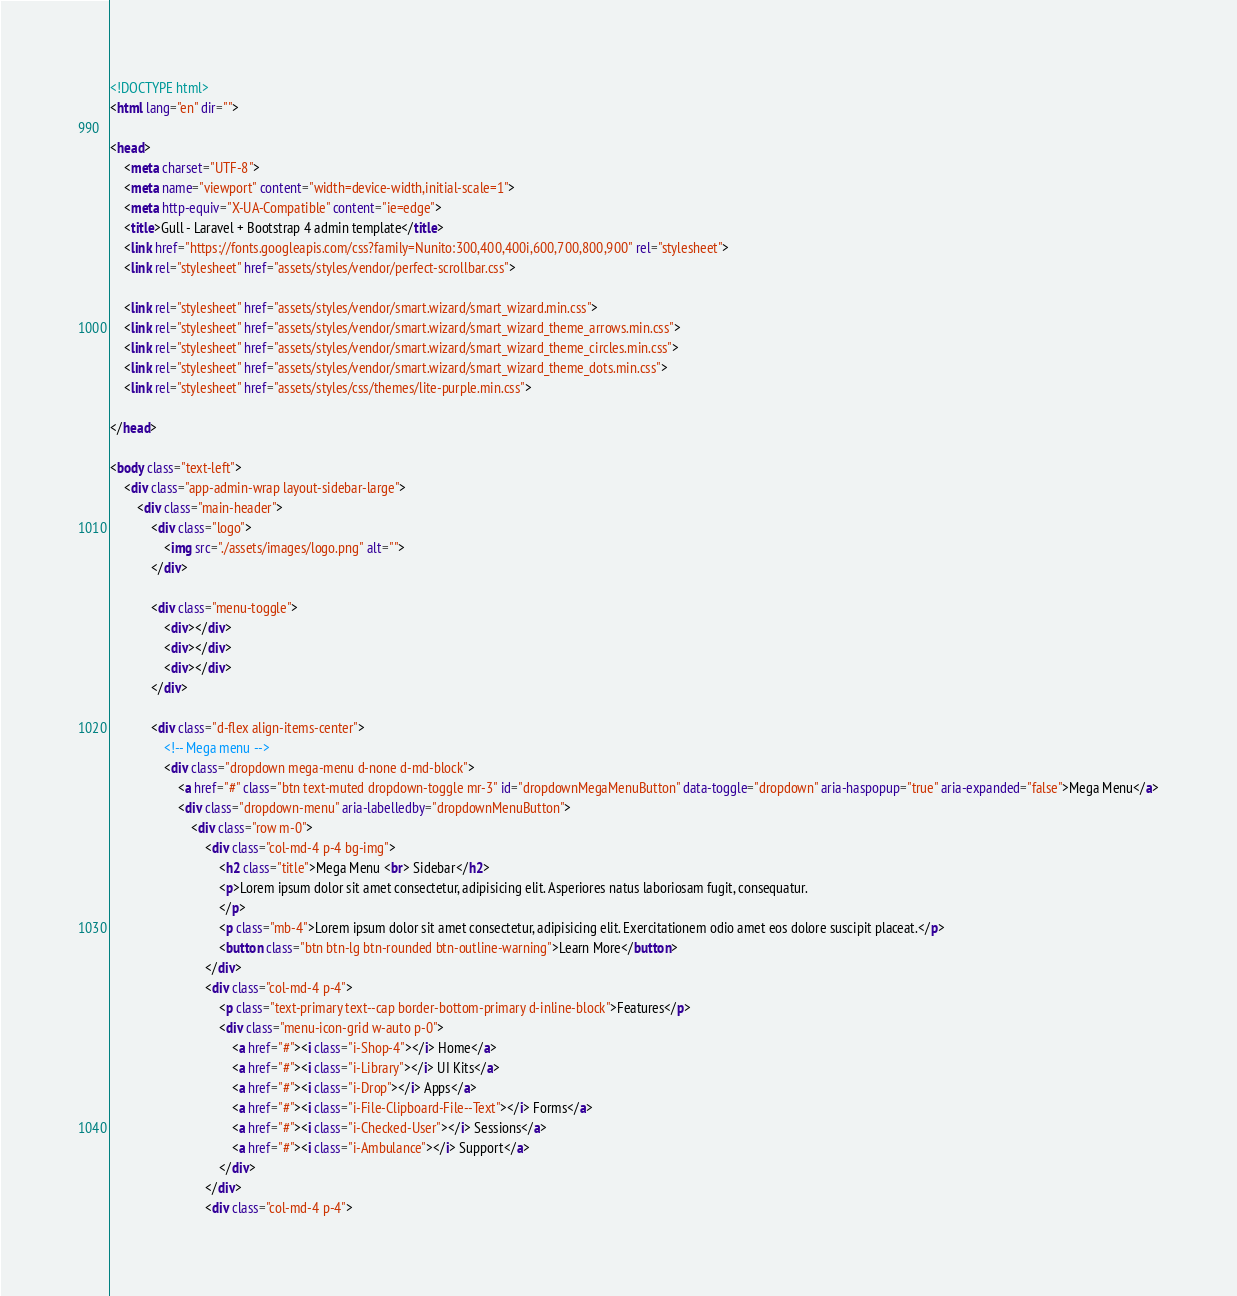<code> <loc_0><loc_0><loc_500><loc_500><_HTML_><!DOCTYPE html>
<html lang="en" dir="">

<head>
    <meta charset="UTF-8">
    <meta name="viewport" content="width=device-width,initial-scale=1">
    <meta http-equiv="X-UA-Compatible" content="ie=edge">
    <title>Gull - Laravel + Bootstrap 4 admin template</title>
    <link href="https://fonts.googleapis.com/css?family=Nunito:300,400,400i,600,700,800,900" rel="stylesheet">
    <link rel="stylesheet" href="assets/styles/vendor/perfect-scrollbar.css">

    <link rel="stylesheet" href="assets/styles/vendor/smart.wizard/smart_wizard.min.css">
    <link rel="stylesheet" href="assets/styles/vendor/smart.wizard/smart_wizard_theme_arrows.min.css">
    <link rel="stylesheet" href="assets/styles/vendor/smart.wizard/smart_wizard_theme_circles.min.css">
    <link rel="stylesheet" href="assets/styles/vendor/smart.wizard/smart_wizard_theme_dots.min.css">
    <link rel="stylesheet" href="assets/styles/css/themes/lite-purple.min.css">

</head>

<body class="text-left">
    <div class="app-admin-wrap layout-sidebar-large">
        <div class="main-header">
            <div class="logo">
                <img src="./assets/images/logo.png" alt="">
            </div>

            <div class="menu-toggle">
                <div></div>
                <div></div>
                <div></div>
            </div>

            <div class="d-flex align-items-center">
                <!-- Mega menu -->
                <div class="dropdown mega-menu d-none d-md-block">
                    <a href="#" class="btn text-muted dropdown-toggle mr-3" id="dropdownMegaMenuButton" data-toggle="dropdown" aria-haspopup="true" aria-expanded="false">Mega Menu</a>
                    <div class="dropdown-menu" aria-labelledby="dropdownMenuButton">
                        <div class="row m-0">
                            <div class="col-md-4 p-4 bg-img">
                                <h2 class="title">Mega Menu <br> Sidebar</h2>
                                <p>Lorem ipsum dolor sit amet consectetur, adipisicing elit. Asperiores natus laboriosam fugit, consequatur.
                                </p>
                                <p class="mb-4">Lorem ipsum dolor sit amet consectetur, adipisicing elit. Exercitationem odio amet eos dolore suscipit placeat.</p>
                                <button class="btn btn-lg btn-rounded btn-outline-warning">Learn More</button>
                            </div>
                            <div class="col-md-4 p-4">
                                <p class="text-primary text--cap border-bottom-primary d-inline-block">Features</p>
                                <div class="menu-icon-grid w-auto p-0">
                                    <a href="#"><i class="i-Shop-4"></i> Home</a>
                                    <a href="#"><i class="i-Library"></i> UI Kits</a>
                                    <a href="#"><i class="i-Drop"></i> Apps</a>
                                    <a href="#"><i class="i-File-Clipboard-File--Text"></i> Forms</a>
                                    <a href="#"><i class="i-Checked-User"></i> Sessions</a>
                                    <a href="#"><i class="i-Ambulance"></i> Support</a>
                                </div>
                            </div>
                            <div class="col-md-4 p-4"></code> 